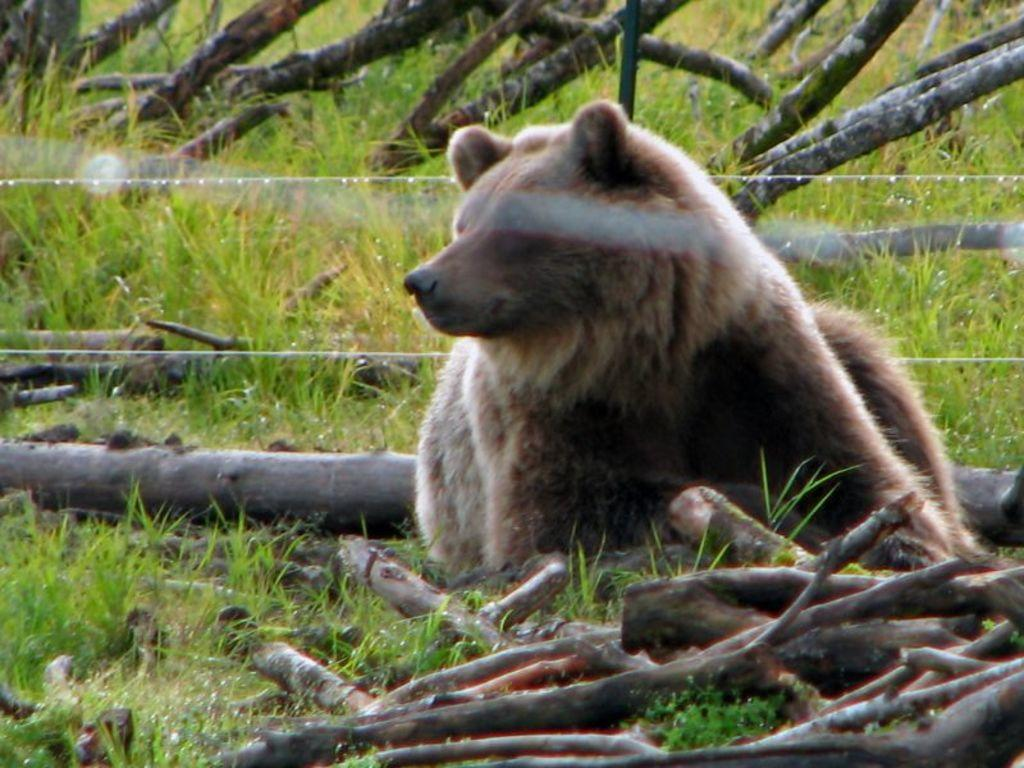What animal is present in the image? There is a bear in the image. Where is the bear located? The bear is in a field. What else can be seen in the field? There are logs in the image. What type of balloon is the bear holding in the image? There is no balloon present in the image; the bear is not holding anything. 